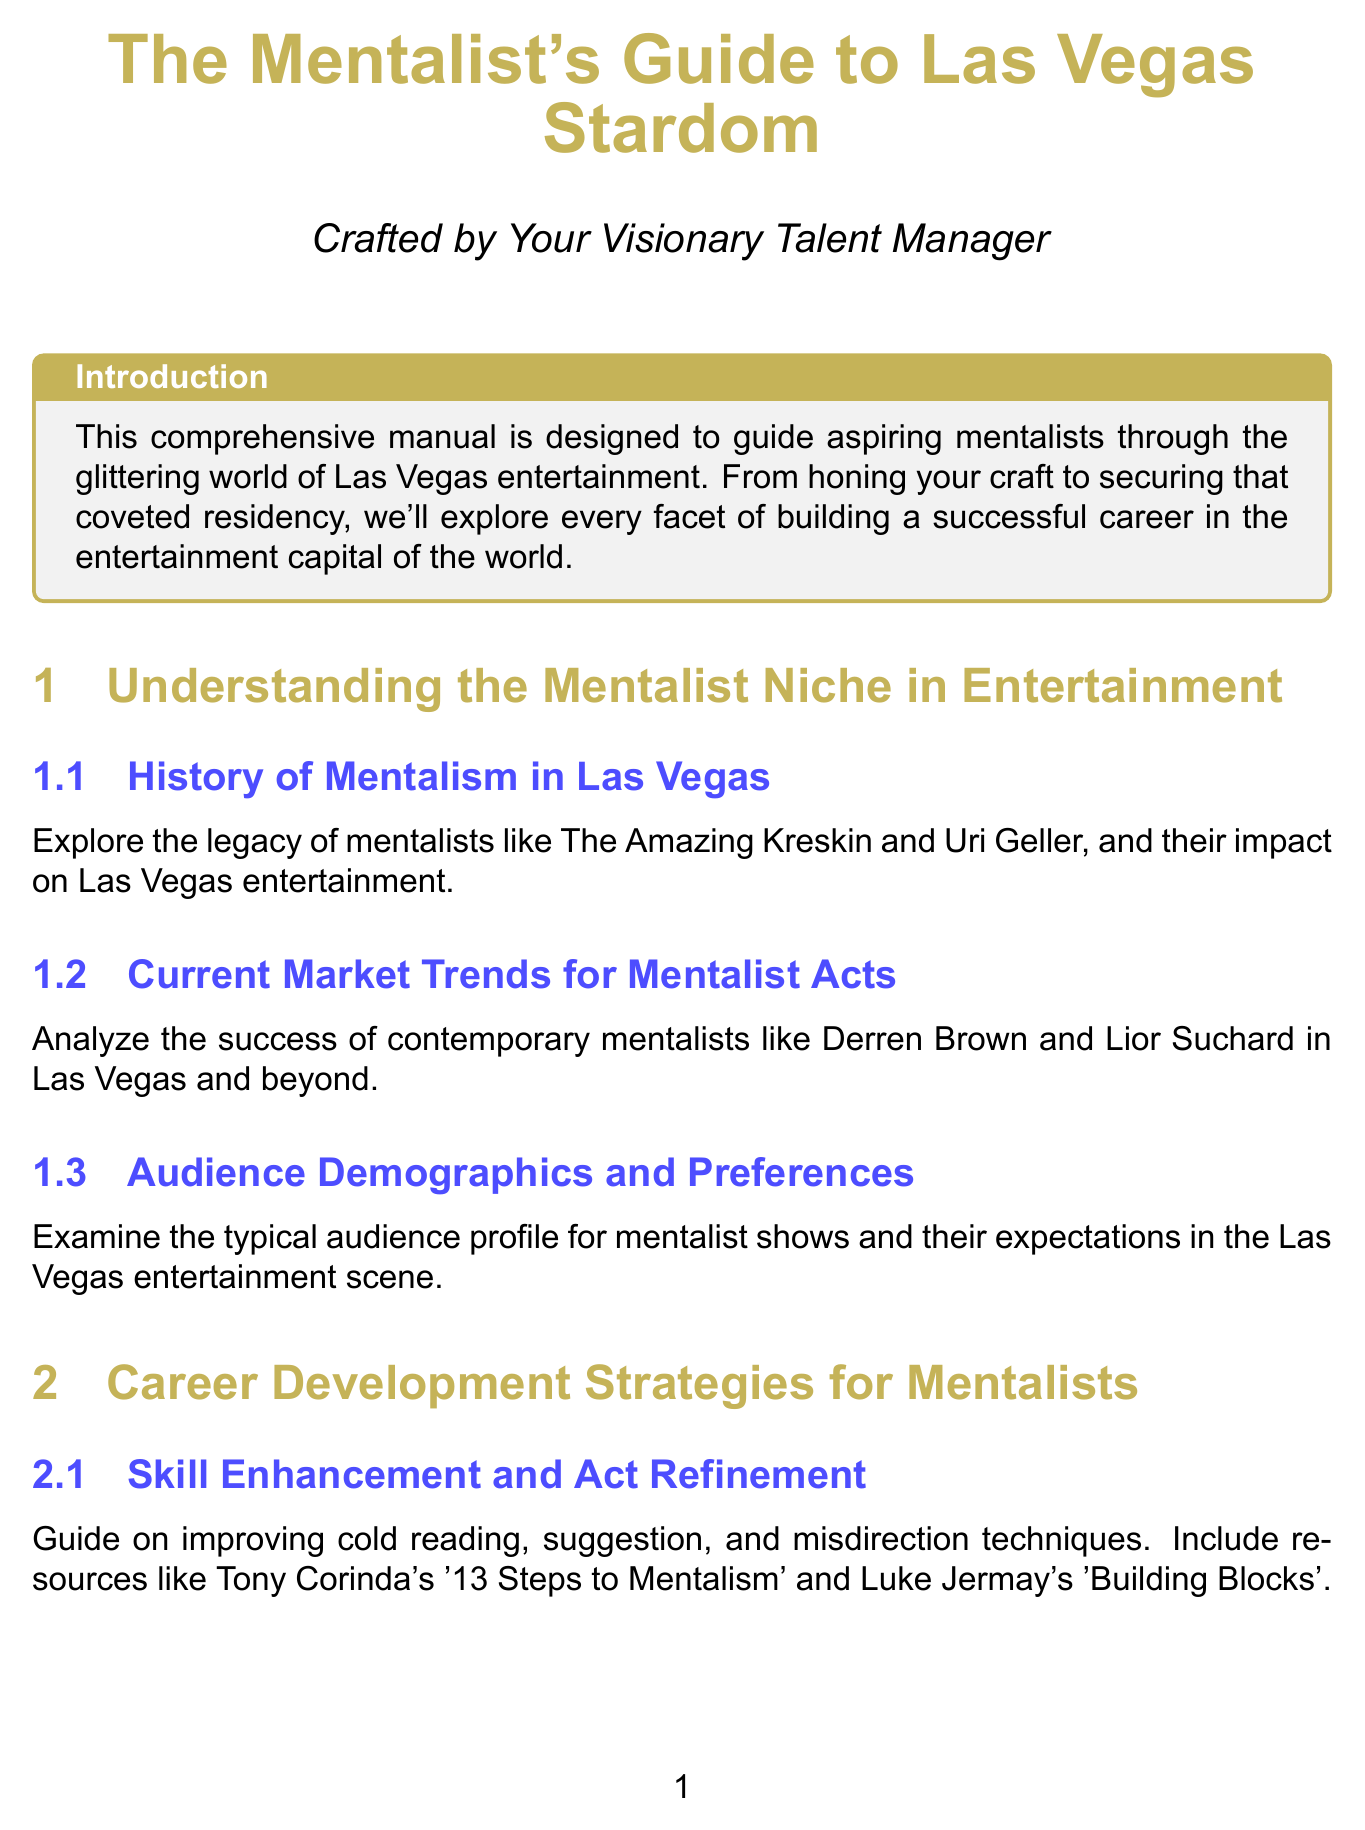What is the focus of the manual? The manual is designed to guide aspiring mentalists through various aspects of building a career in Las Vegas entertainment.
Answer: Career development and brand building for mentalists Who are two legacy mentalists mentioned in the document? The document references influential mentalists who have shaped the niche, such as The Amazing Kreskin and Uri Geller.
Answer: The Amazing Kreskin and Uri Geller What is one technique for skill enhancement mentioned? The content suggests improving techniques like cold reading as part of act refinement for mentalists.
Answer: Cold reading Which platform is suggested for building an online presence? The manual advises leveraging social media to enhance visibility, particularly mentioning Instagram and TikTok.
Answer: Instagram and TikTok What is an element that should be included in a unique selling proposition? The document mentions differentiation strategies borrowed from established acts, particularly blending different performance styles.
Answer: Differentiation strategies What type of insurance is recommended for performers? The manual discusses necessary insurance coverage options relevant to performing artists.
Answer: Hiscox Entertainment Insurance What is an essential aspect of securing a Las Vegas residency? According to the document, navigating contract negotiations is a crucial factor in obtaining a residency at Las Vegas venues.
Answer: Contract negotiations What firm is suggested for investment advice? The manual recommends working with financial advisors who specialize in the entertainment industry for managing finances.
Answer: Business Management International (BMI) What publication is mentioned for media relations? The content provides tips on collaborating with entertainment journalists to enhance publicity, referencing a specific publication.
Answer: Las Vegas Review-Journal 